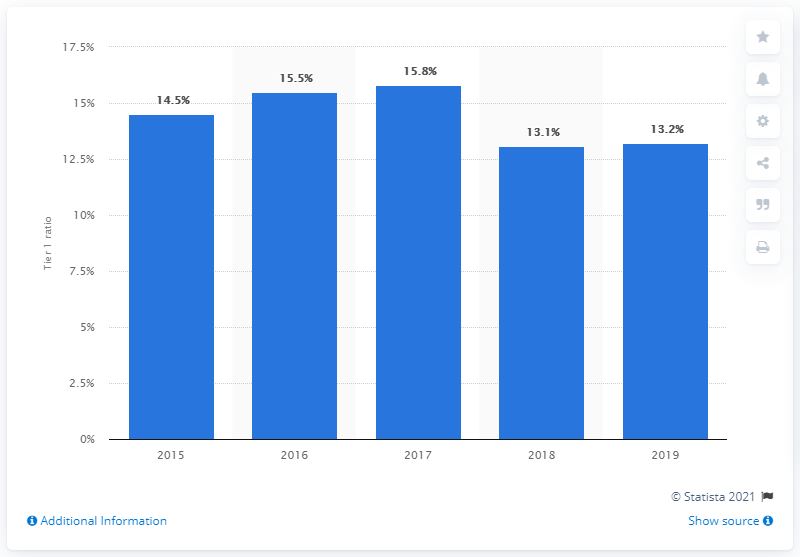What trend does the chart show for Crédit Agricole's Tier 1 ratio over the years presented? The chart illustrates a decreasing trend in the Tier 1 ratio of Crédit Agricole from 2015 to 2019. It started at 14.5% in 2015, peaked at 15.8% in 2017, and subsequently dropped to 13.2% in 2019. 